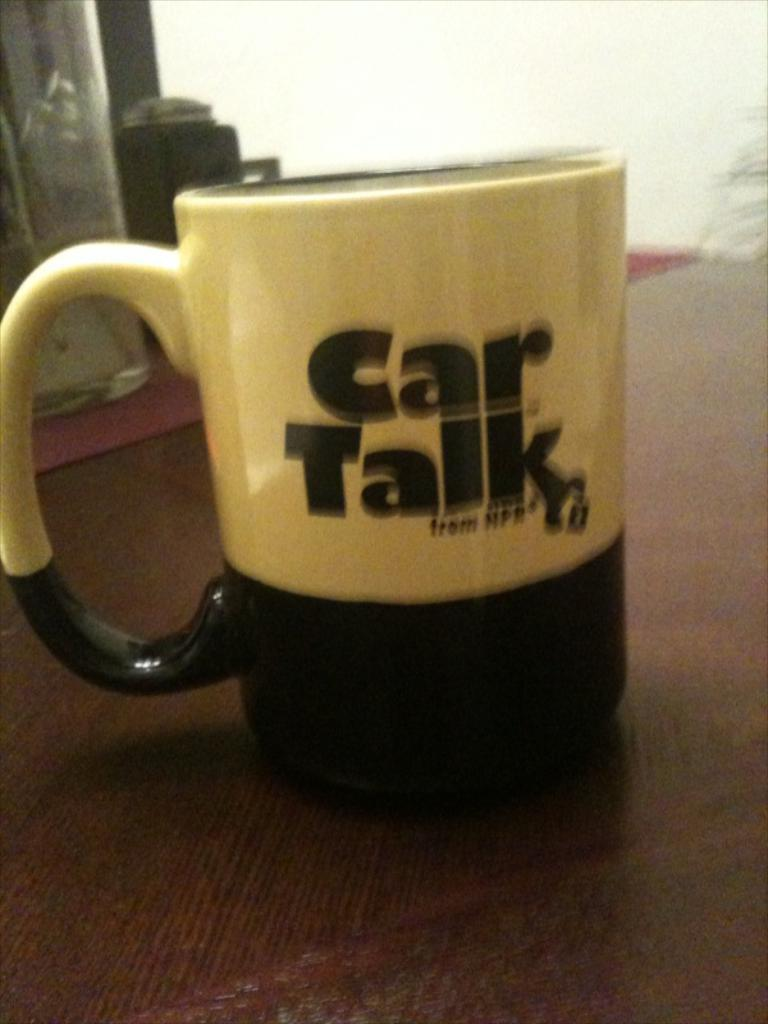<image>
Provide a brief description of the given image. A coffee mug advertises an NPR show about cars. 